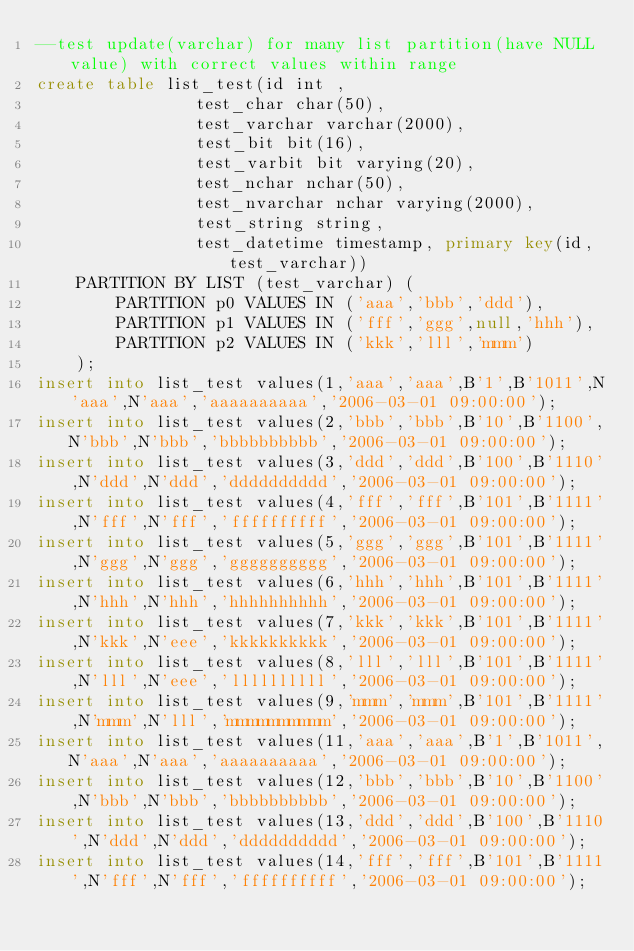<code> <loc_0><loc_0><loc_500><loc_500><_SQL_>--test update(varchar) for many list partition(have NULL value) with correct values within range
create table list_test(id int ,
				test_char char(50),
				test_varchar varchar(2000),
				test_bit bit(16),
				test_varbit bit varying(20),
				test_nchar nchar(50),
				test_nvarchar nchar varying(2000),
				test_string string,
				test_datetime timestamp, primary key(id,test_varchar))
	PARTITION BY LIST (test_varchar) (
	    PARTITION p0 VALUES IN ('aaa','bbb','ddd'),
	    PARTITION p1 VALUES IN ('fff','ggg',null,'hhh'),
	    PARTITION p2 VALUES IN ('kkk','lll','mmm')
	);
insert into list_test values(1,'aaa','aaa',B'1',B'1011',N'aaa',N'aaa','aaaaaaaaaa','2006-03-01 09:00:00');   
insert into list_test values(2,'bbb','bbb',B'10',B'1100',N'bbb',N'bbb','bbbbbbbbbb','2006-03-01 09:00:00');  
insert into list_test values(3,'ddd','ddd',B'100',B'1110',N'ddd',N'ddd','dddddddddd','2006-03-01 09:00:00'); 
insert into list_test values(4,'fff','fff',B'101',B'1111',N'fff',N'fff','ffffffffff','2006-03-01 09:00:00'); 
insert into list_test values(5,'ggg','ggg',B'101',B'1111',N'ggg',N'ggg','gggggggggg','2006-03-01 09:00:00'); 
insert into list_test values(6,'hhh','hhh',B'101',B'1111',N'hhh',N'hhh','hhhhhhhhhh','2006-03-01 09:00:00'); 
insert into list_test values(7,'kkk','kkk',B'101',B'1111',N'kkk',N'eee','kkkkkkkkkk','2006-03-01 09:00:00'); 
insert into list_test values(8,'lll','lll',B'101',B'1111',N'lll',N'eee','llllllllll','2006-03-01 09:00:00'); 
insert into list_test values(9,'mmm','mmm',B'101',B'1111',N'mmm',N'lll','mmmmmmmmmm','2006-03-01 09:00:00'); 
insert into list_test values(11,'aaa','aaa',B'1',B'1011',N'aaa',N'aaa','aaaaaaaaaa','2006-03-01 09:00:00');  
insert into list_test values(12,'bbb','bbb',B'10',B'1100',N'bbb',N'bbb','bbbbbbbbbb','2006-03-01 09:00:00'); 
insert into list_test values(13,'ddd','ddd',B'100',B'1110',N'ddd',N'ddd','dddddddddd','2006-03-01 09:00:00');
insert into list_test values(14,'fff','fff',B'101',B'1111',N'fff',N'fff','ffffffffff','2006-03-01 09:00:00');</code> 